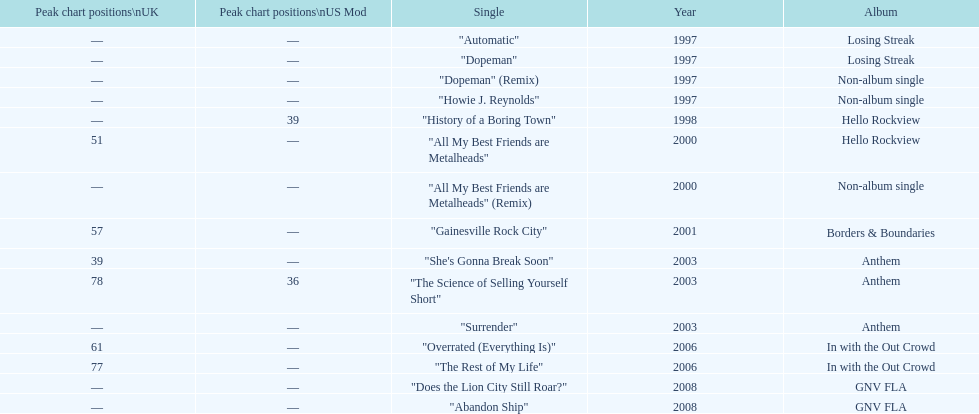Which year has the most singles? 1997. 